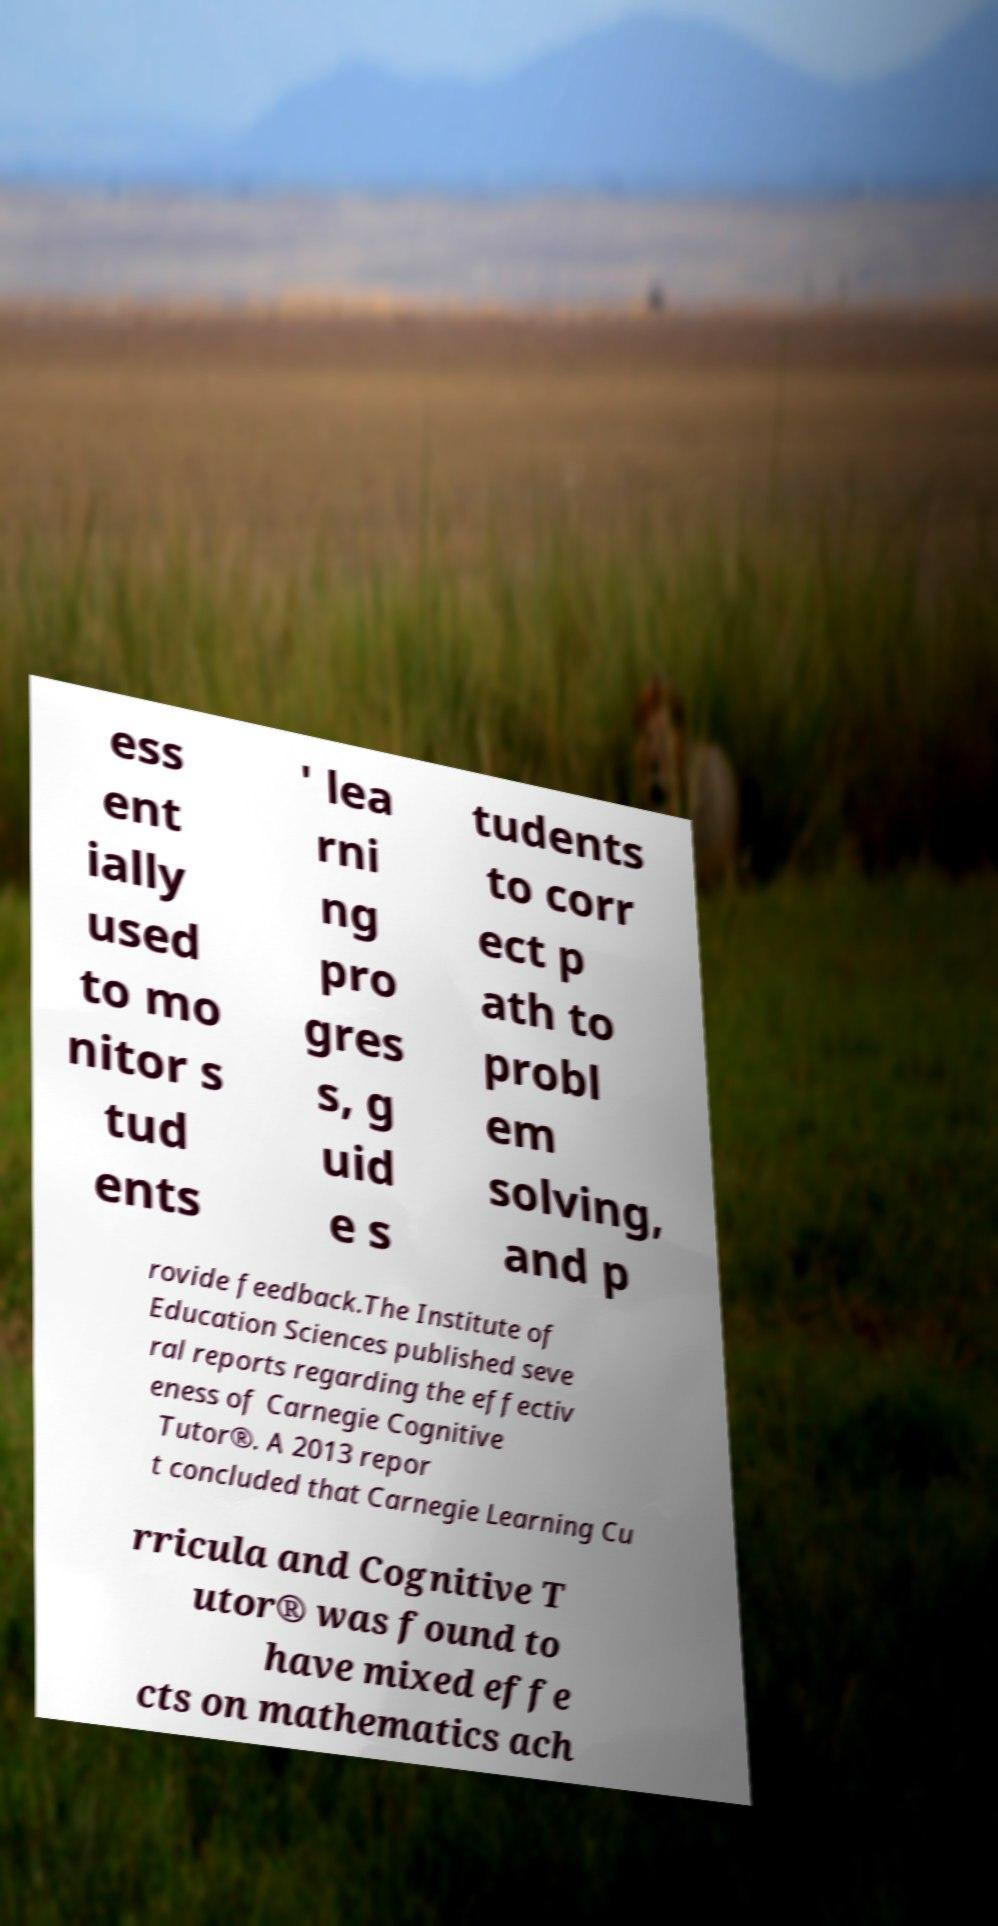I need the written content from this picture converted into text. Can you do that? ess ent ially used to mo nitor s tud ents ' lea rni ng pro gres s, g uid e s tudents to corr ect p ath to probl em solving, and p rovide feedback.The Institute of Education Sciences published seve ral reports regarding the effectiv eness of Carnegie Cognitive Tutor®. A 2013 repor t concluded that Carnegie Learning Cu rricula and Cognitive T utor® was found to have mixed effe cts on mathematics ach 